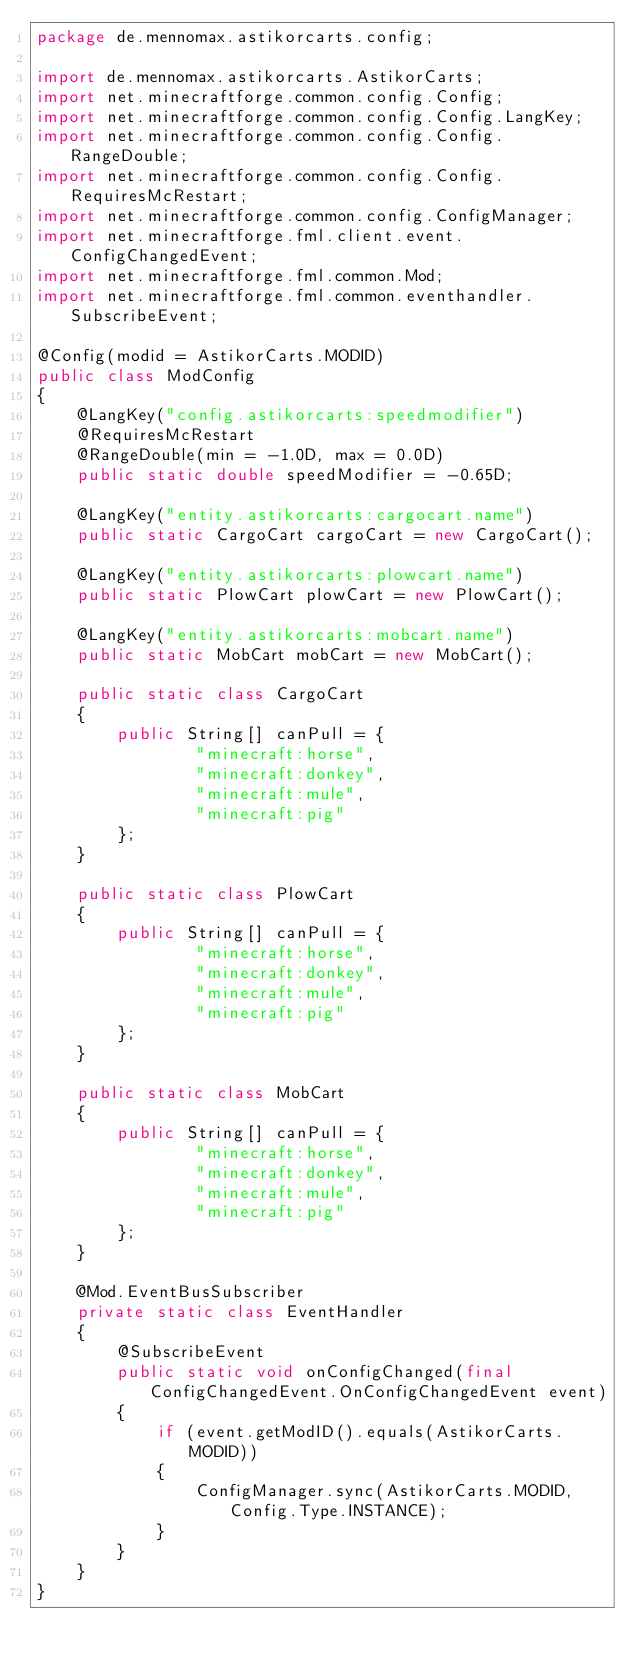Convert code to text. <code><loc_0><loc_0><loc_500><loc_500><_Java_>package de.mennomax.astikorcarts.config;

import de.mennomax.astikorcarts.AstikorCarts;
import net.minecraftforge.common.config.Config;
import net.minecraftforge.common.config.Config.LangKey;
import net.minecraftforge.common.config.Config.RangeDouble;
import net.minecraftforge.common.config.Config.RequiresMcRestart;
import net.minecraftforge.common.config.ConfigManager;
import net.minecraftforge.fml.client.event.ConfigChangedEvent;
import net.minecraftforge.fml.common.Mod;
import net.minecraftforge.fml.common.eventhandler.SubscribeEvent;

@Config(modid = AstikorCarts.MODID)
public class ModConfig
{
    @LangKey("config.astikorcarts:speedmodifier")
    @RequiresMcRestart
    @RangeDouble(min = -1.0D, max = 0.0D)
    public static double speedModifier = -0.65D;
    
    @LangKey("entity.astikorcarts:cargocart.name")
    public static CargoCart cargoCart = new CargoCart();

    @LangKey("entity.astikorcarts:plowcart.name")
    public static PlowCart plowCart = new PlowCart();
    
    @LangKey("entity.astikorcarts:mobcart.name")
    public static MobCart mobCart = new MobCart();

    public static class CargoCart
    {
        public String[] canPull = {
                "minecraft:horse",
                "minecraft:donkey",
                "minecraft:mule",
                "minecraft:pig"
        };
    }

    public static class PlowCart
    {
        public String[] canPull = {
                "minecraft:horse",
                "minecraft:donkey",
                "minecraft:mule",
                "minecraft:pig"
        };
    }
    
    public static class MobCart
    {
        public String[] canPull = {
                "minecraft:horse",
                "minecraft:donkey",
                "minecraft:mule",
                "minecraft:pig"
        };
    }

    @Mod.EventBusSubscriber
    private static class EventHandler
    {
        @SubscribeEvent
        public static void onConfigChanged(final ConfigChangedEvent.OnConfigChangedEvent event)
        {
            if (event.getModID().equals(AstikorCarts.MODID))
            {
                ConfigManager.sync(AstikorCarts.MODID, Config.Type.INSTANCE);
            }
        }
    }
}
</code> 